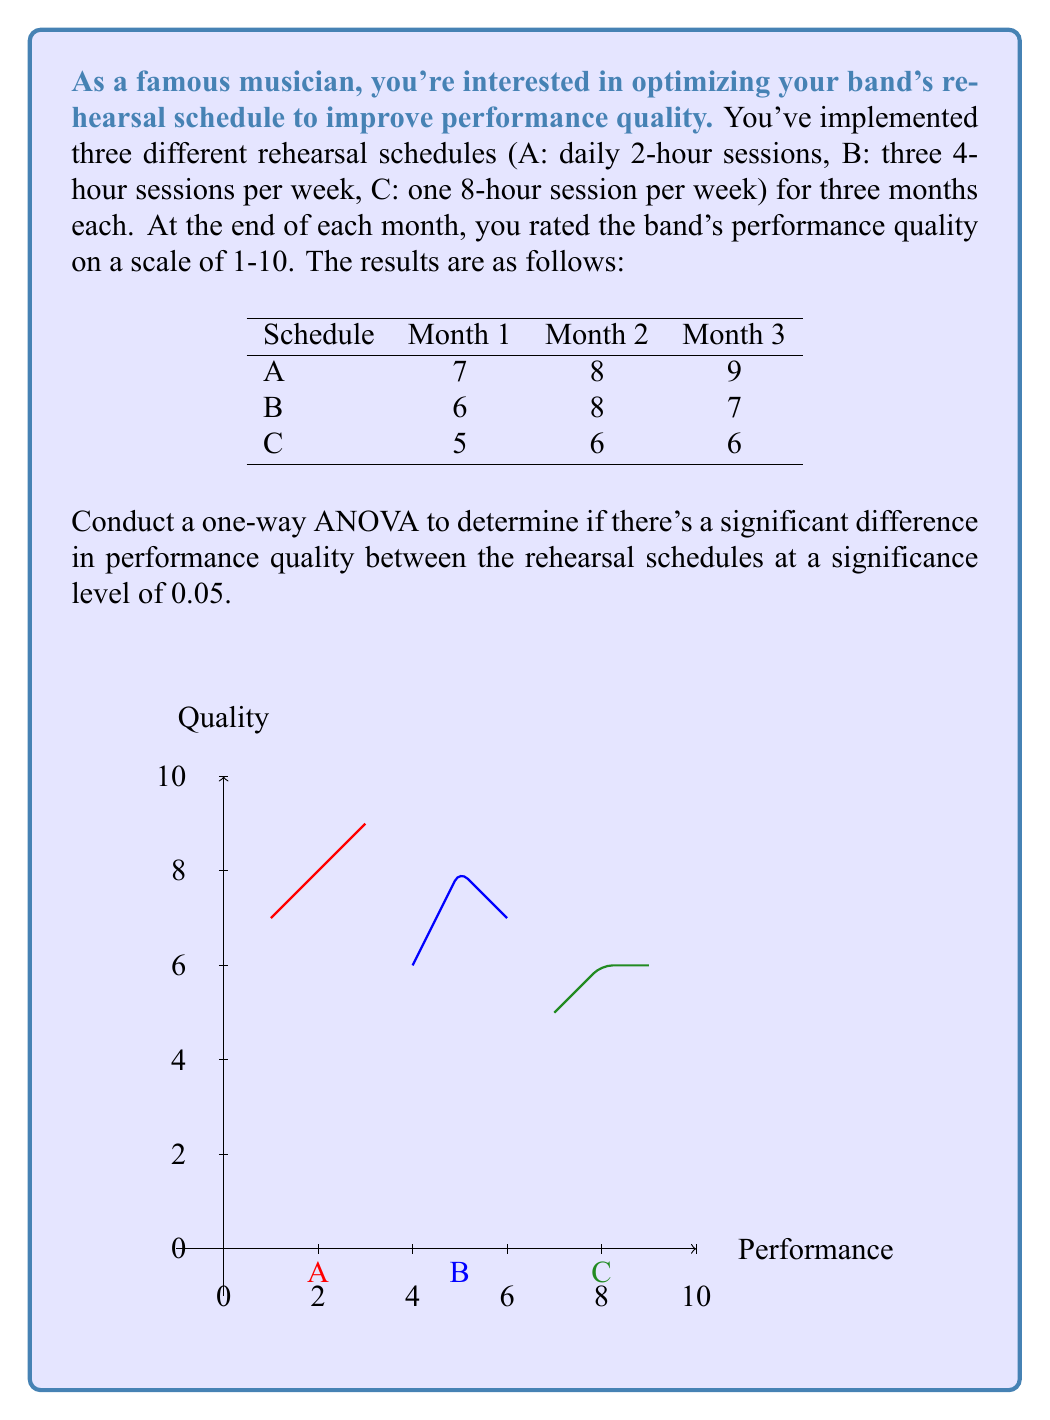Help me with this question. Let's conduct the one-way ANOVA step-by-step:

1) Calculate the mean for each group:
   $\bar{X}_A = \frac{7 + 8 + 9}{3} = 8$
   $\bar{X}_B = \frac{6 + 8 + 7}{3} = 7$
   $\bar{X}_C = \frac{5 + 6 + 6}{3} = 5.67$

2) Calculate the grand mean:
   $\bar{X} = \frac{8 + 7 + 5.67}{3} = 6.89$

3) Calculate SSB (Sum of Squares Between groups):
   $SSB = 3[(8 - 6.89)^2 + (7 - 6.89)^2 + (5.67 - 6.89)^2] = 8.22$

4) Calculate SSW (Sum of Squares Within groups):
   $SSW_A = (7-8)^2 + (8-8)^2 + (9-8)^2 = 2$
   $SSW_B = (6-7)^2 + (8-7)^2 + (7-7)^2 = 2$
   $SSW_C = (5-5.67)^2 + (6-5.67)^2 + (6-5.67)^2 = 1.33$
   $SSW = 2 + 2 + 1.33 = 5.33$

5) Calculate degrees of freedom:
   $df_{between} = k - 1 = 3 - 1 = 2$
   $df_{within} = N - k = 9 - 3 = 6$
   where k is the number of groups and N is the total number of observations.

6) Calculate Mean Square Between (MSB) and Mean Square Within (MSW):
   $MSB = \frac{SSB}{df_{between}} = \frac{8.22}{2} = 4.11$
   $MSW = \frac{SSW}{df_{within}} = \frac{5.33}{6} = 0.89$

7) Calculate the F-statistic:
   $F = \frac{MSB}{MSW} = \frac{4.11}{0.89} = 4.62$

8) Find the critical F-value:
   For $\alpha = 0.05$, $df_{between} = 2$, and $df_{within} = 6$, the critical F-value is approximately 5.14.

9) Compare the F-statistic to the critical F-value:
   Since 4.62 < 5.14, we fail to reject the null hypothesis.
Answer: $F(2,6) = 4.62, p > 0.05$. No significant difference between schedules. 